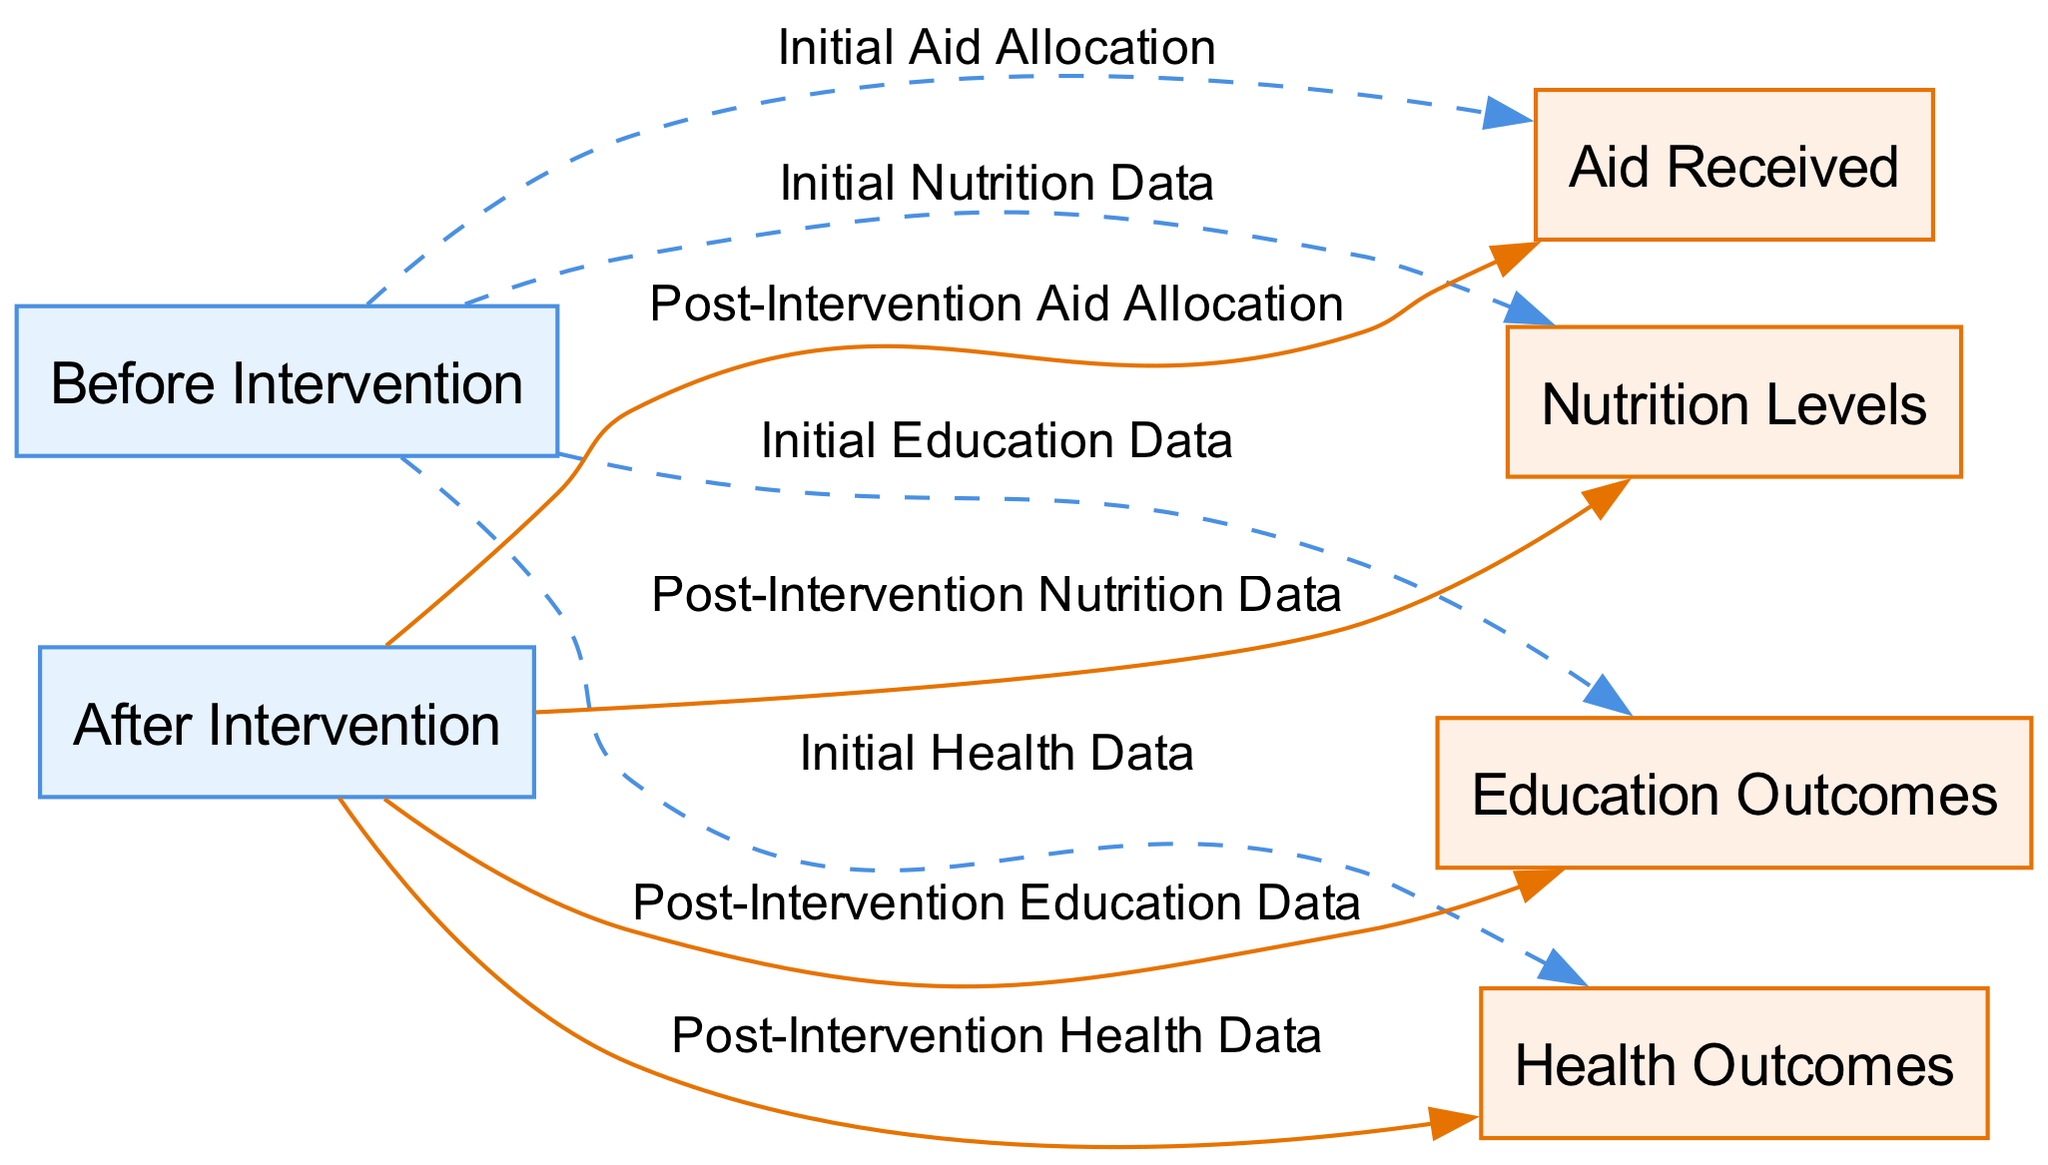What are the nodes representing in the diagram? The nodes in the diagram represent different stages and outcomes related to aid effectiveness, specifically before and after intervention, as well as the types of outcomes such as aid received, health outcomes, education outcomes, and nutrition levels.
Answer: Before and after intervention, aid received, health outcomes, education outcomes, nutrition levels How many nodes are there in the diagram? Counting the nodes provided in the elements section, there are a total of six nodes, categorized into two intervention stages and four outcome types.
Answer: Six What does the edge between "before intervention" and "health outcomes" represent? This edge denotes the relationship between the initial state of the health data before the intervention occurs, indicating how health outcomes were monitored prior to the introduction of aid.
Answer: Initial Health Data Which node receives aid allocation after intervention? The node representing "aid received" receives aid allocation after the intervention, as shown by the edge labeled "Post-Intervention Aid Allocation" stemming from "after intervention."
Answer: Aid Received What type of relationship is represented by the edge from "after intervention" to "education outcomes"? The edge is depicted as a solid line, which indicates a direct influence or outcome relationship where education data is observed post-intervention.
Answer: Post-Intervention Education Data Explain the difference in the nature of edges before and after the intervention. The edges before the intervention are dashed, indicating preliminary data and initial conditions, while the edges after the intervention are solid, demonstrating confirmed outcomes resulting from the intervention efforts.
Answer: Dashed for before, solid for after Which outcome is linked to both intervention stages? Nutrition levels are linked to both intervention stages, with initial data captured before the intervention and ongoing assessment post-intervention.
Answer: Nutrition Levels What can be inferred about the aid received before and after the intervention? The diagram implies that there is a comparison of the aid received before and after the intervention, which can be used to evaluate the effectiveness of the allocated aid based on subsequent outcome data.
Answer: Comparison of aid effectiveness 